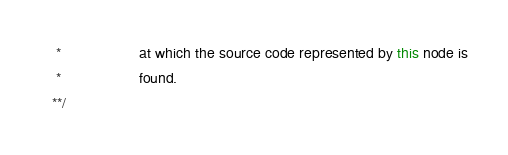<code> <loc_0><loc_0><loc_500><loc_500><_Java_>    *                   at which the source code represented by this node is
    *                   found.
   **/</code> 